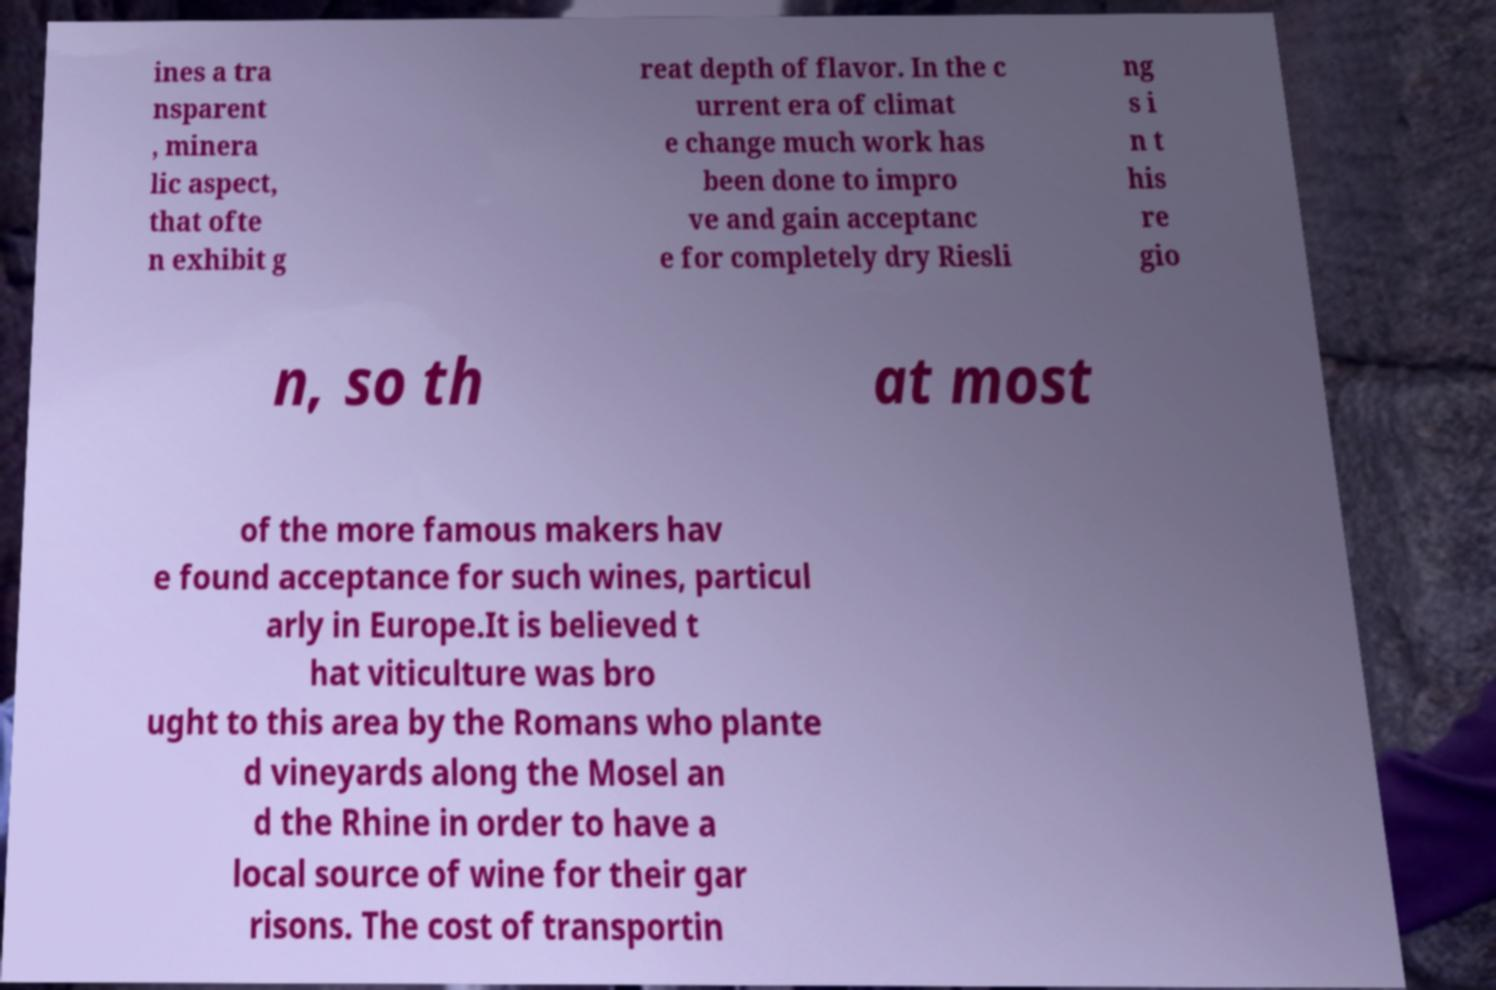Could you extract and type out the text from this image? ines a tra nsparent , minera lic aspect, that ofte n exhibit g reat depth of flavor. In the c urrent era of climat e change much work has been done to impro ve and gain acceptanc e for completely dry Riesli ng s i n t his re gio n, so th at most of the more famous makers hav e found acceptance for such wines, particul arly in Europe.It is believed t hat viticulture was bro ught to this area by the Romans who plante d vineyards along the Mosel an d the Rhine in order to have a local source of wine for their gar risons. The cost of transportin 